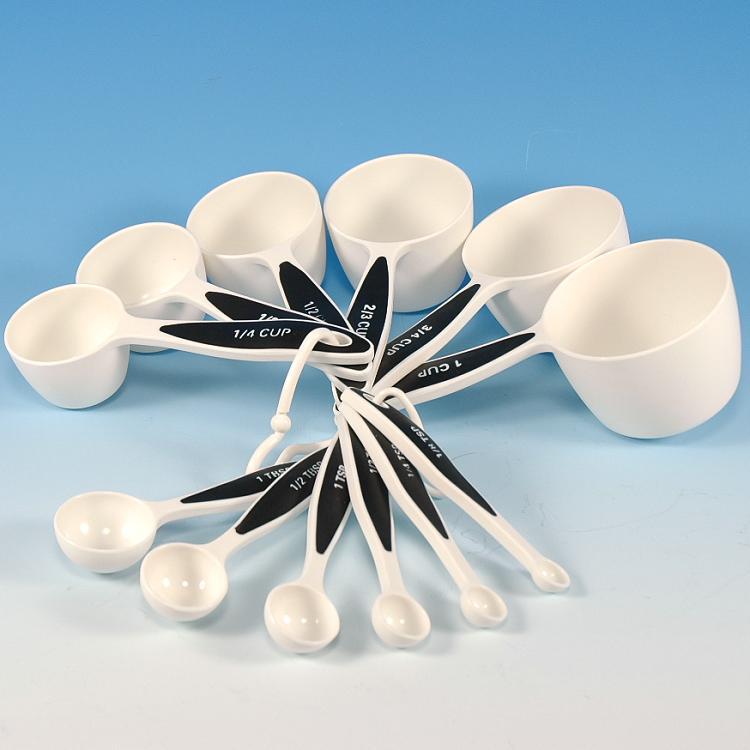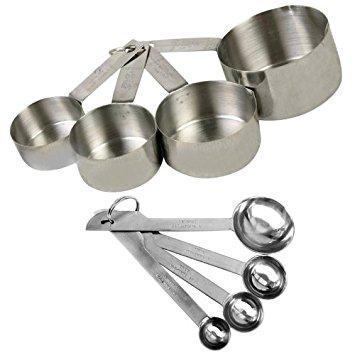The first image is the image on the left, the second image is the image on the right. Given the left and right images, does the statement "One the set of measuring spoons is white with black handles." hold true? Answer yes or no. Yes. 